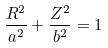<formula> <loc_0><loc_0><loc_500><loc_500>\frac { R ^ { 2 } } { a ^ { 2 } } + \frac { Z ^ { 2 } } { b ^ { 2 } } = 1</formula> 